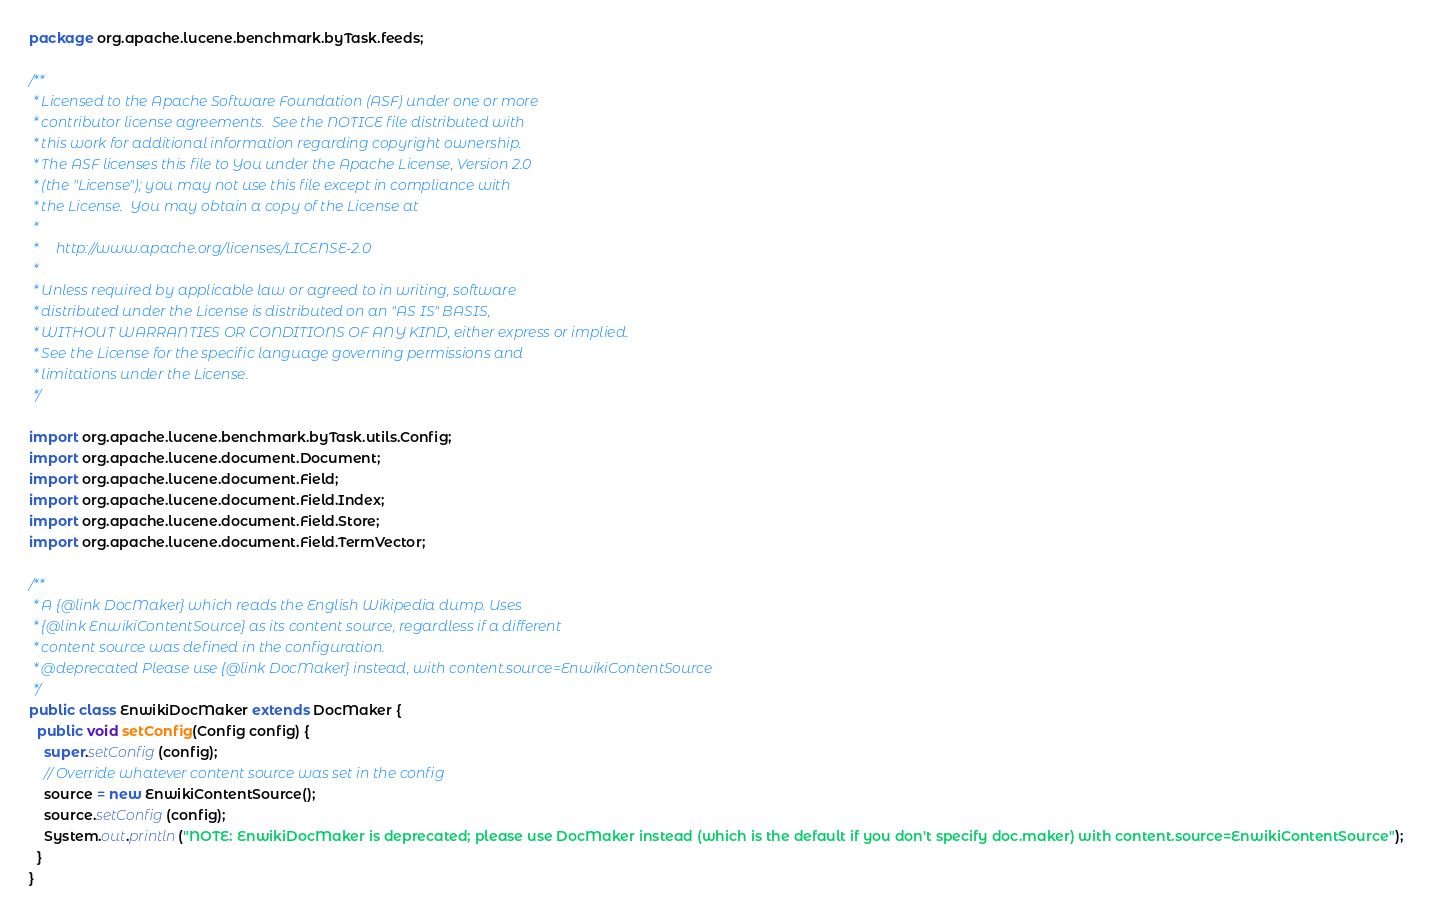<code> <loc_0><loc_0><loc_500><loc_500><_Java_>package org.apache.lucene.benchmark.byTask.feeds;

/**
 * Licensed to the Apache Software Foundation (ASF) under one or more
 * contributor license agreements.  See the NOTICE file distributed with
 * this work for additional information regarding copyright ownership.
 * The ASF licenses this file to You under the Apache License, Version 2.0
 * (the "License"); you may not use this file except in compliance with
 * the License.  You may obtain a copy of the License at
 *
 *     http://www.apache.org/licenses/LICENSE-2.0
 *
 * Unless required by applicable law or agreed to in writing, software
 * distributed under the License is distributed on an "AS IS" BASIS,
 * WITHOUT WARRANTIES OR CONDITIONS OF ANY KIND, either express or implied.
 * See the License for the specific language governing permissions and
 * limitations under the License.
 */

import org.apache.lucene.benchmark.byTask.utils.Config;
import org.apache.lucene.document.Document;
import org.apache.lucene.document.Field;
import org.apache.lucene.document.Field.Index;
import org.apache.lucene.document.Field.Store;
import org.apache.lucene.document.Field.TermVector;

/**
 * A {@link DocMaker} which reads the English Wikipedia dump. Uses
 * {@link EnwikiContentSource} as its content source, regardless if a different
 * content source was defined in the configuration.
 * @deprecated Please use {@link DocMaker} instead, with content.source=EnwikiContentSource
 */
public class EnwikiDocMaker extends DocMaker {
  public void setConfig(Config config) {
    super.setConfig(config);
    // Override whatever content source was set in the config
    source = new EnwikiContentSource();
    source.setConfig(config);
    System.out.println("NOTE: EnwikiDocMaker is deprecated; please use DocMaker instead (which is the default if you don't specify doc.maker) with content.source=EnwikiContentSource");
  }
}
</code> 